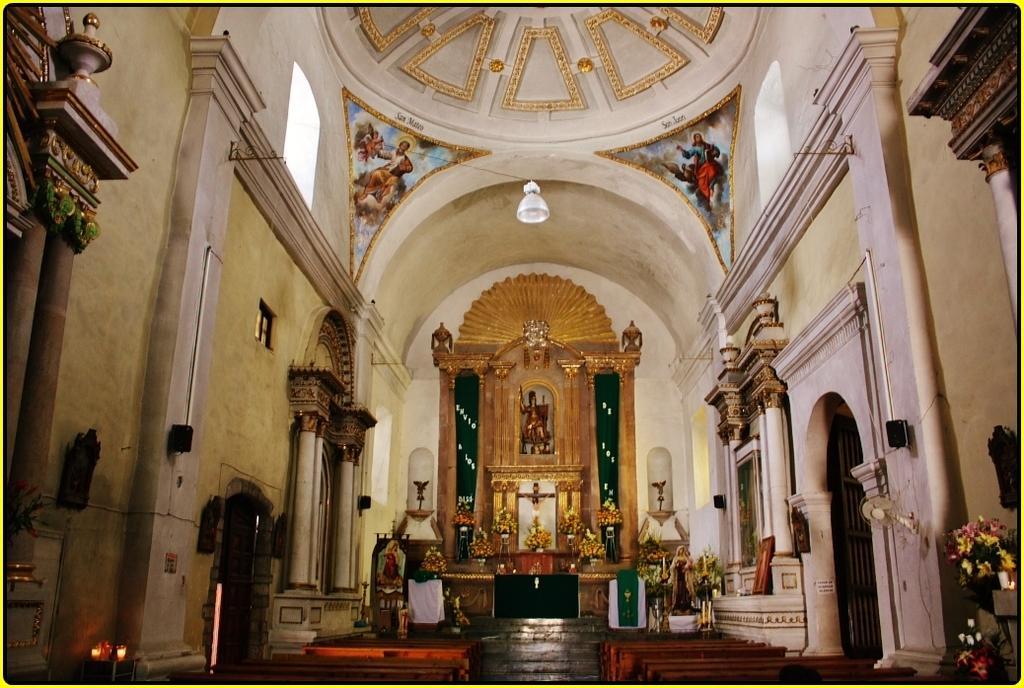Can you describe this image briefly? In the picture we can see an inside view of the church with some light to the ceiling and some, Jesus Christ paintings and to the wall we can see sculptures with a gold color around it and front of it we can see some flowers are decorated and to the walls we can see some pillars. 